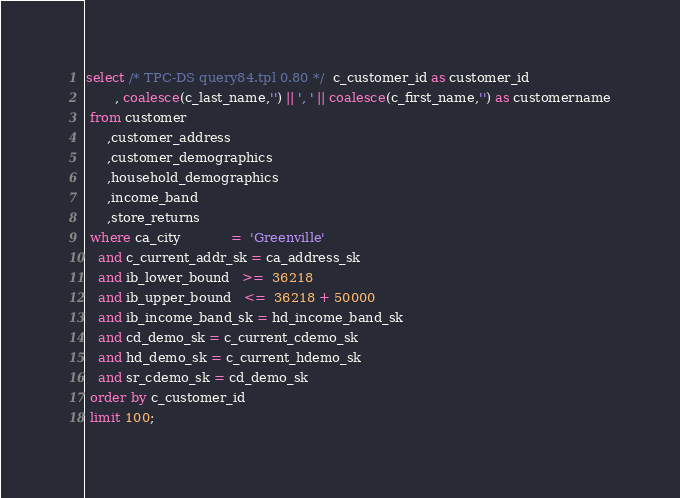<code> <loc_0><loc_0><loc_500><loc_500><_SQL_>select /* TPC-DS query84.tpl 0.80 */  c_customer_id as customer_id
       , coalesce(c_last_name,'') || ', ' || coalesce(c_first_name,'') as customername
 from customer
     ,customer_address
     ,customer_demographics
     ,household_demographics
     ,income_band
     ,store_returns
 where ca_city	        =  'Greenville'
   and c_current_addr_sk = ca_address_sk
   and ib_lower_bound   >=  36218
   and ib_upper_bound   <=  36218 + 50000
   and ib_income_band_sk = hd_income_band_sk
   and cd_demo_sk = c_current_cdemo_sk
   and hd_demo_sk = c_current_hdemo_sk
   and sr_cdemo_sk = cd_demo_sk
 order by c_customer_id
 limit 100;</code> 